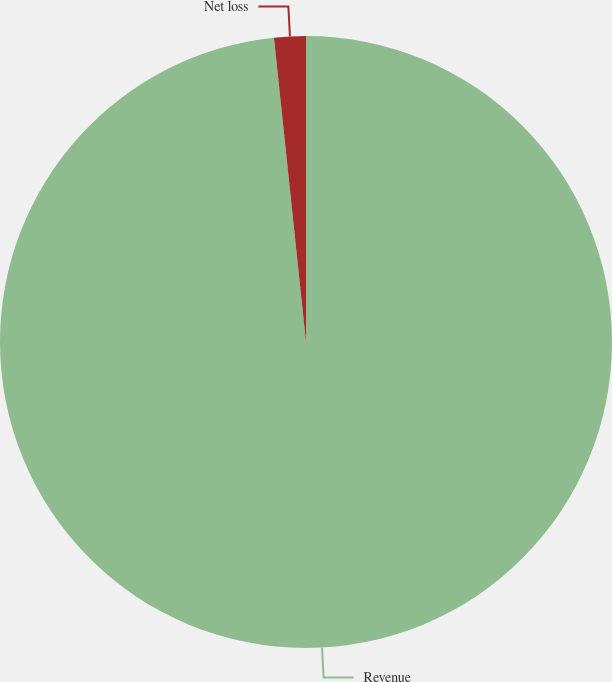Convert chart. <chart><loc_0><loc_0><loc_500><loc_500><pie_chart><fcel>Revenue<fcel>Net loss<nl><fcel>98.33%<fcel>1.67%<nl></chart> 